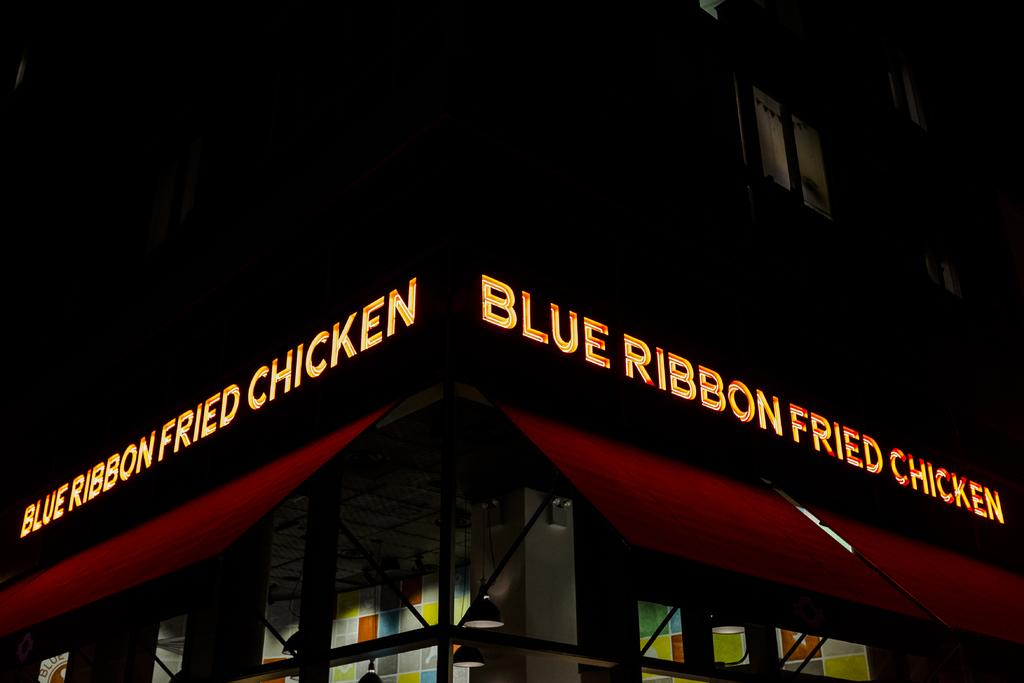What is the main subject of the image? The main subject of the image is a building. What specific features can be observed on the building? The building has windows. Are there any words or letters visible on the building? Yes, there is text visible on the building. What type of flight can be seen taking off from the building in the image? There is no flight visible in the image; it only features a building with windows and text. How many feet tall is the building in the image? The height of the building cannot be determined from the image alone. 